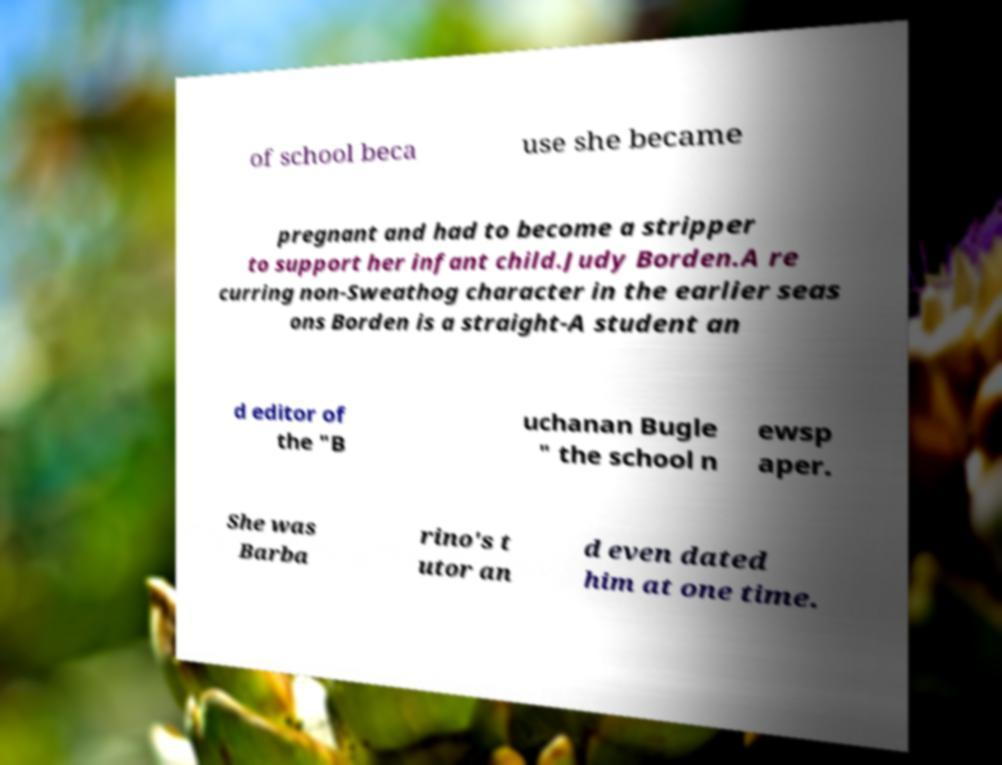Please read and relay the text visible in this image. What does it say? of school beca use she became pregnant and had to become a stripper to support her infant child.Judy Borden.A re curring non-Sweathog character in the earlier seas ons Borden is a straight-A student an d editor of the "B uchanan Bugle " the school n ewsp aper. She was Barba rino's t utor an d even dated him at one time. 